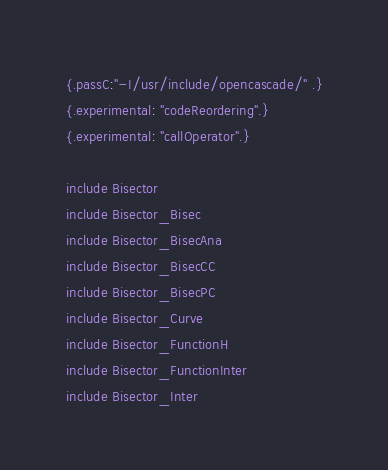<code> <loc_0><loc_0><loc_500><loc_500><_Nim_>{.passC:"-I/usr/include/opencascade/" .}
{.experimental: "codeReordering".}
{.experimental: "callOperator".}

include Bisector
include Bisector_Bisec
include Bisector_BisecAna
include Bisector_BisecCC
include Bisector_BisecPC
include Bisector_Curve
include Bisector_FunctionH
include Bisector_FunctionInter
include Bisector_Inter</code> 